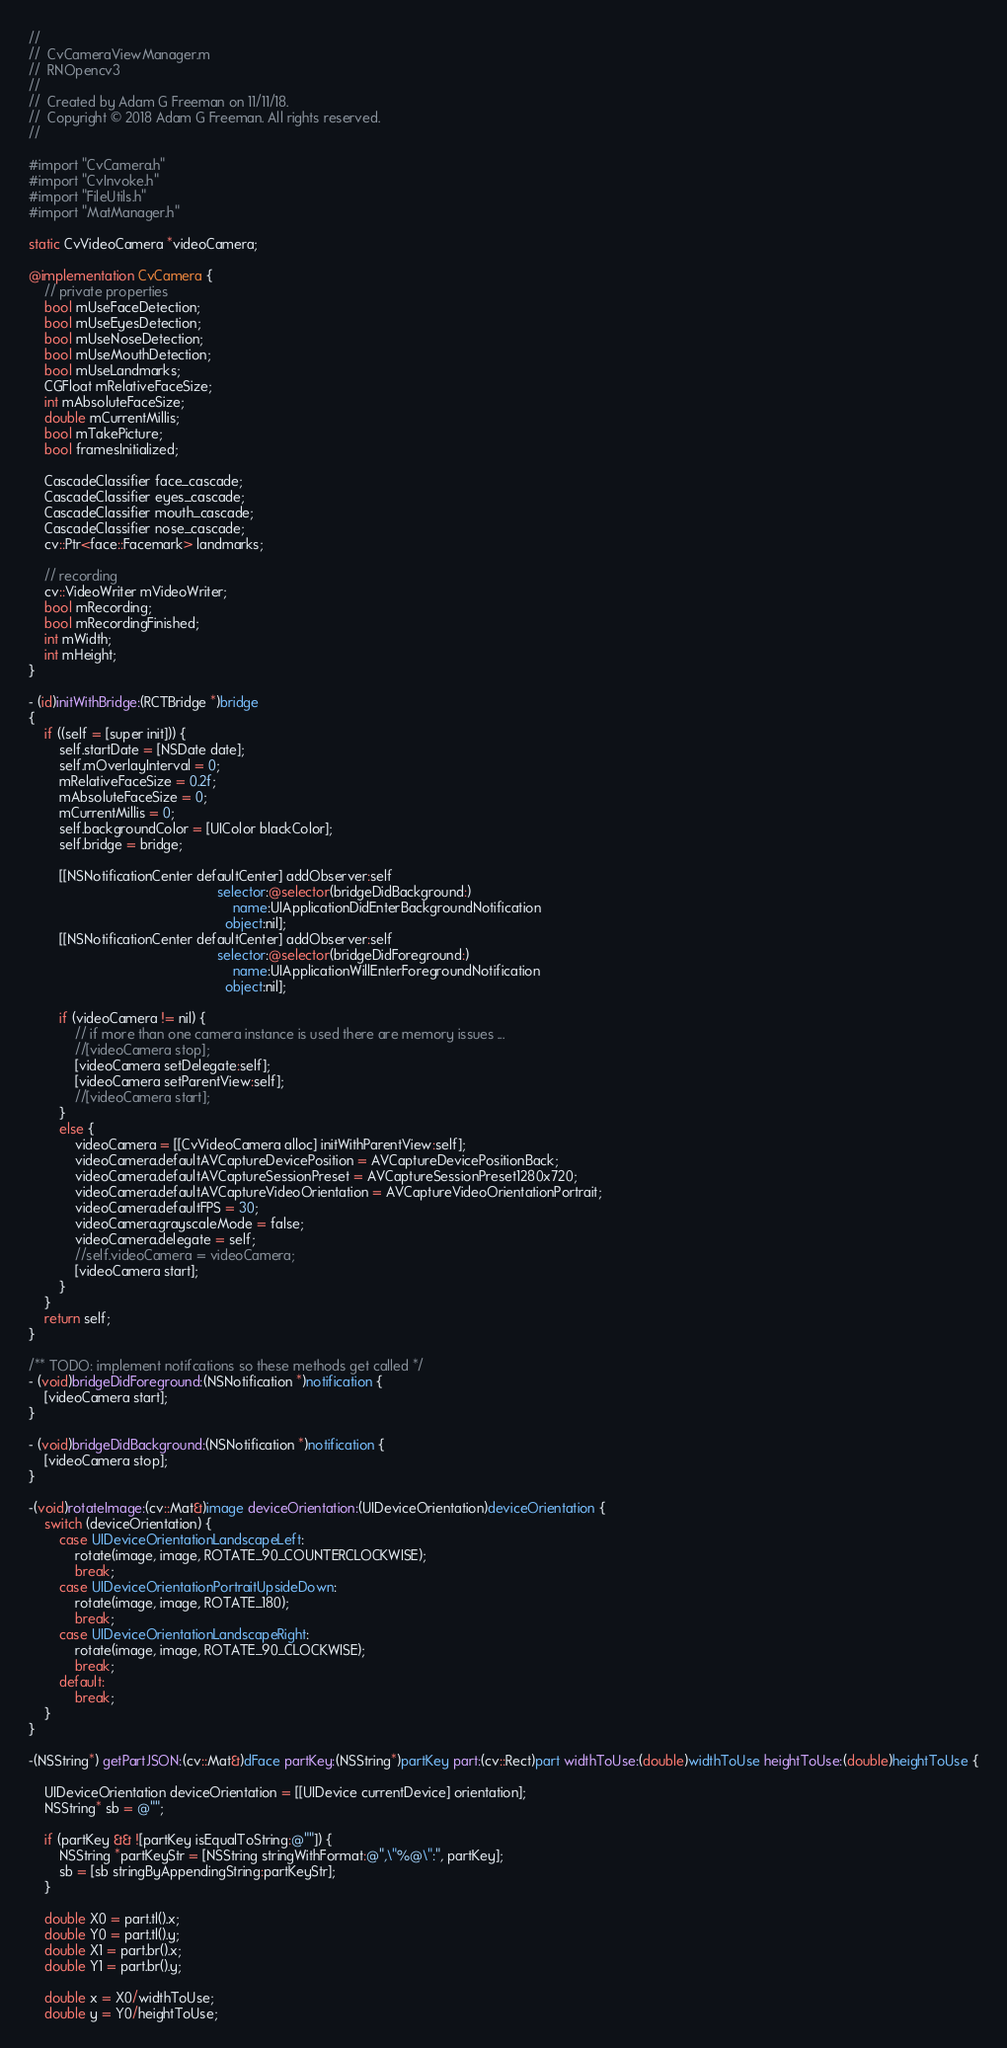Convert code to text. <code><loc_0><loc_0><loc_500><loc_500><_ObjectiveC_>//
//  CvCameraViewManager.m
//  RNOpencv3
//
//  Created by Adam G Freeman on 11/11/18.
//  Copyright © 2018 Adam G Freeman. All rights reserved.
//

#import "CvCamera.h"
#import "CvInvoke.h"
#import "FileUtils.h"
#import "MatManager.h"

static CvVideoCamera *videoCamera;

@implementation CvCamera {
    // private properties
    bool mUseFaceDetection;
    bool mUseEyesDetection;
    bool mUseNoseDetection;
    bool mUseMouthDetection;
    bool mUseLandmarks;
    CGFloat mRelativeFaceSize;
    int mAbsoluteFaceSize;
    double mCurrentMillis;
    bool mTakePicture;
    bool framesInitialized;
    
    CascadeClassifier face_cascade;
    CascadeClassifier eyes_cascade;
    CascadeClassifier mouth_cascade;
    CascadeClassifier nose_cascade;
    cv::Ptr<face::Facemark> landmarks;
    
    // recording
    cv::VideoWriter mVideoWriter;
    bool mRecording;
    bool mRecordingFinished;
    int mWidth;
    int mHeight;
}

- (id)initWithBridge:(RCTBridge *)bridge
{
    if ((self = [super init])) {
        self.startDate = [NSDate date];
        self.mOverlayInterval = 0;
        mRelativeFaceSize = 0.2f;
        mAbsoluteFaceSize = 0;
        mCurrentMillis = 0;
        self.backgroundColor = [UIColor blackColor];
        self.bridge = bridge;
        
        [[NSNotificationCenter defaultCenter] addObserver:self
                                                 selector:@selector(bridgeDidBackground:)
                                                     name:UIApplicationDidEnterBackgroundNotification
                                                   object:nil];
        [[NSNotificationCenter defaultCenter] addObserver:self
                                                 selector:@selector(bridgeDidForeground:)
                                                     name:UIApplicationWillEnterForegroundNotification
                                                   object:nil];
        
        if (videoCamera != nil) {
            // if more than one camera instance is used there are memory issues ...
            //[videoCamera stop];
            [videoCamera setDelegate:self];
            [videoCamera setParentView:self];
            //[videoCamera start];
        }
        else {
            videoCamera = [[CvVideoCamera alloc] initWithParentView:self];
            videoCamera.defaultAVCaptureDevicePosition = AVCaptureDevicePositionBack;
            videoCamera.defaultAVCaptureSessionPreset = AVCaptureSessionPreset1280x720;
            videoCamera.defaultAVCaptureVideoOrientation = AVCaptureVideoOrientationPortrait;
            videoCamera.defaultFPS = 30;
            videoCamera.grayscaleMode = false;
            videoCamera.delegate = self;
            //self.videoCamera = videoCamera;
            [videoCamera start];
        }
    }
    return self;
}

/** TODO: implement notifcations so these methods get called */
- (void)bridgeDidForeground:(NSNotification *)notification {
    [videoCamera start];
}

- (void)bridgeDidBackground:(NSNotification *)notification {
    [videoCamera stop];
}

-(void)rotateImage:(cv::Mat&)image deviceOrientation:(UIDeviceOrientation)deviceOrientation {
    switch (deviceOrientation) {
        case UIDeviceOrientationLandscapeLeft:
            rotate(image, image, ROTATE_90_COUNTERCLOCKWISE);
            break;
        case UIDeviceOrientationPortraitUpsideDown:
            rotate(image, image, ROTATE_180);
            break;
        case UIDeviceOrientationLandscapeRight:
            rotate(image, image, ROTATE_90_CLOCKWISE);
            break;
        default:
            break;
    }
}

-(NSString*) getPartJSON:(cv::Mat&)dFace partKey:(NSString*)partKey part:(cv::Rect)part widthToUse:(double)widthToUse heightToUse:(double)heightToUse {

    UIDeviceOrientation deviceOrientation = [[UIDevice currentDevice] orientation];
    NSString* sb = @"";

    if (partKey && ![partKey isEqualToString:@""]) {
        NSString *partKeyStr = [NSString stringWithFormat:@",\"%@\":", partKey];
        sb = [sb stringByAppendingString:partKeyStr];
    }

    double X0 = part.tl().x;
    double Y0 = part.tl().y;
    double X1 = part.br().x;
    double Y1 = part.br().y;

    double x = X0/widthToUse;
    double y = Y0/heightToUse;</code> 